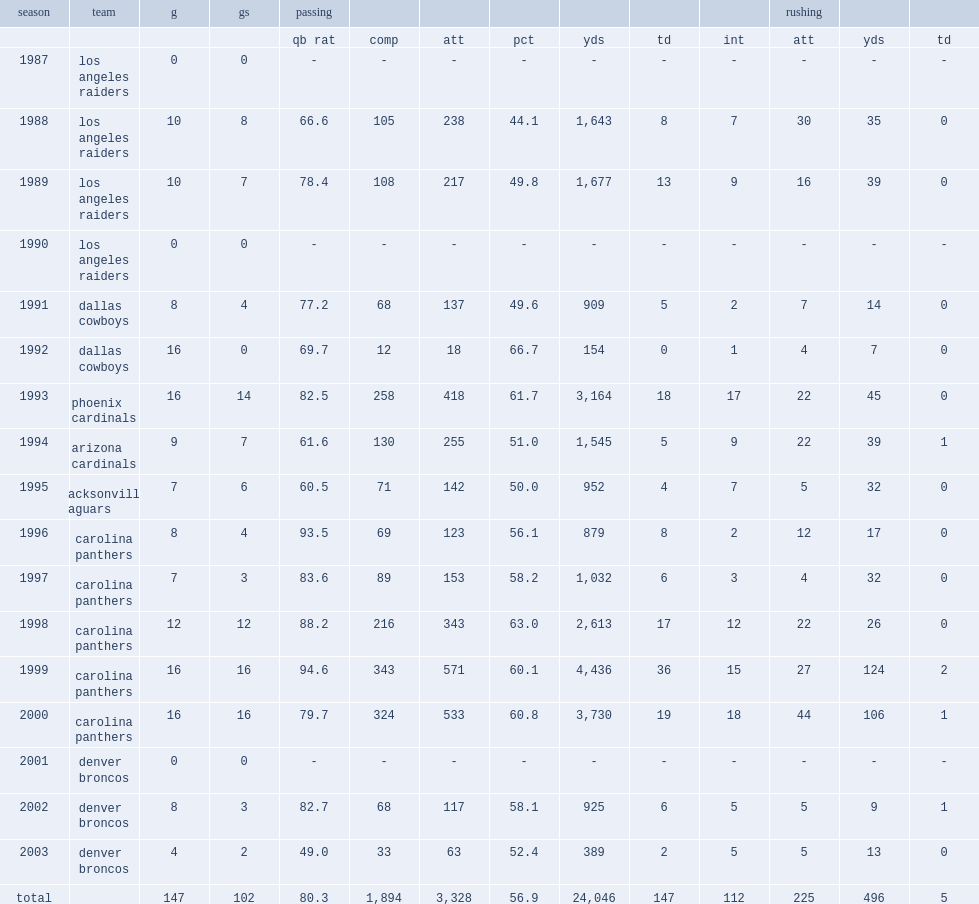In 1999, how many completions did steve beuerlein make? 343.0. 